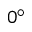Convert formula to latex. <formula><loc_0><loc_0><loc_500><loc_500>0 ^ { \circ }</formula> 